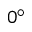Convert formula to latex. <formula><loc_0><loc_0><loc_500><loc_500>0 ^ { \circ }</formula> 